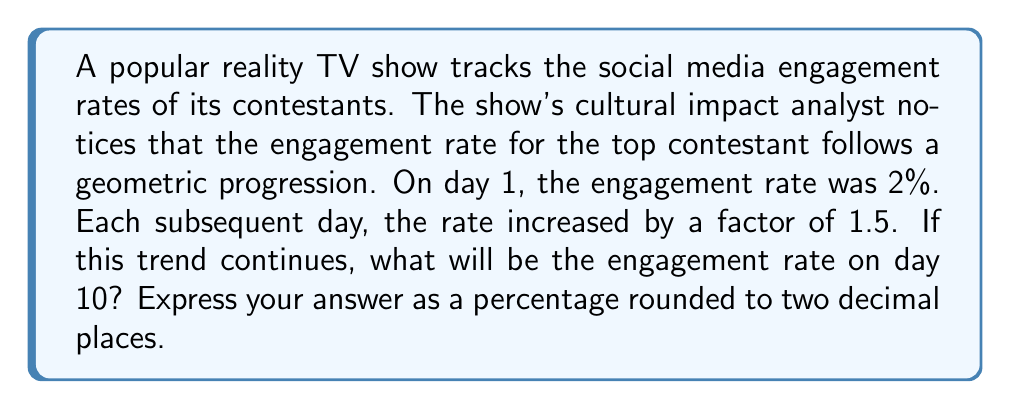Teach me how to tackle this problem. Let's approach this step-by-step:

1) In a geometric progression, each term is a constant multiple of the previous term. Here, that constant (common ratio) is 1.5.

2) We can represent this progression as:
   $$a_n = a_1 \cdot r^{n-1}$$
   where $a_n$ is the nth term, $a_1$ is the first term, r is the common ratio, and n is the position of the term.

3) We're given:
   $a_1 = 2\%$ (initial rate)
   $r = 1.5$ (growth factor)
   $n = 10$ (we want the 10th day)

4) Plugging these into our formula:
   $$a_{10} = 2\% \cdot 1.5^{10-1}$$

5) Simplify:
   $$a_{10} = 2\% \cdot 1.5^9$$

6) Calculate:
   $$a_{10} = 2\% \cdot 38.4434...$$
   $$a_{10} = 76.8868...$$

7) Rounding to two decimal places:
   $$a_{10} \approx 76.89\%$$

This progression represents a dramatic increase in engagement, which could be analyzed for its implications on viewer behavior and the show's cultural impact.
Answer: 76.89% 